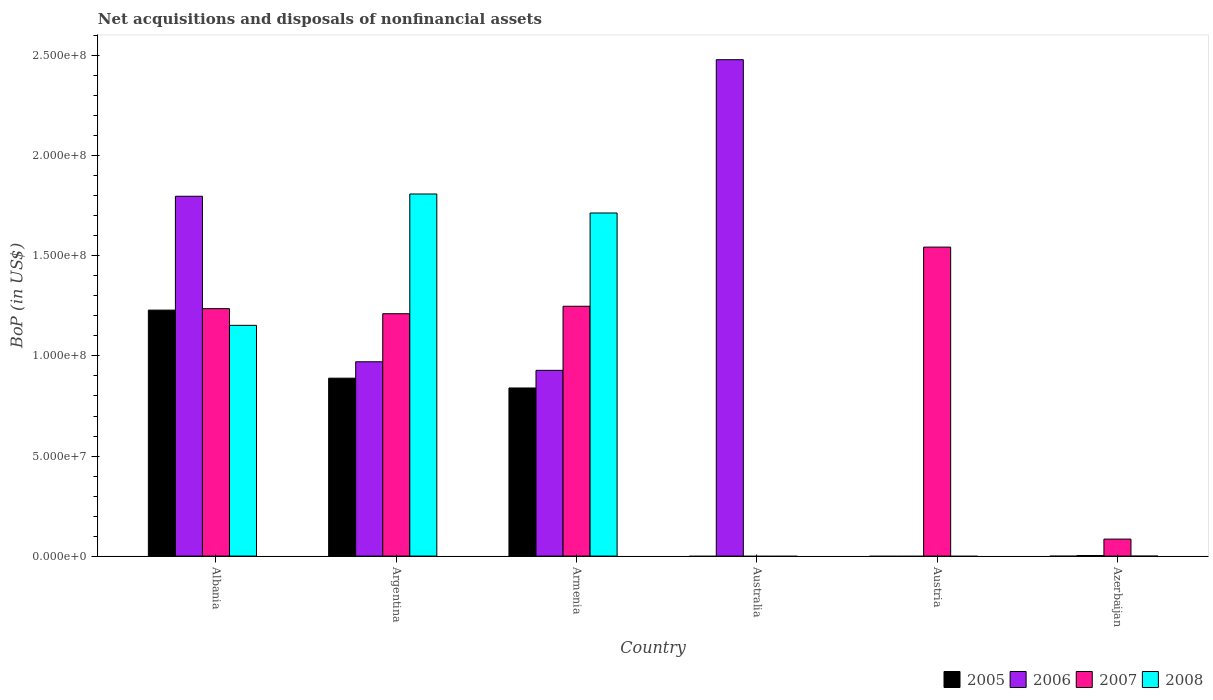How many different coloured bars are there?
Provide a succinct answer. 4. Are the number of bars per tick equal to the number of legend labels?
Provide a succinct answer. No. How many bars are there on the 5th tick from the left?
Provide a succinct answer. 1. How many bars are there on the 5th tick from the right?
Offer a terse response. 4. What is the label of the 1st group of bars from the left?
Offer a terse response. Albania. What is the Balance of Payments in 2008 in Armenia?
Your response must be concise. 1.71e+08. Across all countries, what is the maximum Balance of Payments in 2007?
Keep it short and to the point. 1.54e+08. What is the total Balance of Payments in 2005 in the graph?
Make the answer very short. 2.96e+08. What is the difference between the Balance of Payments in 2006 in Armenia and that in Azerbaijan?
Provide a short and direct response. 9.25e+07. What is the difference between the Balance of Payments in 2006 in Armenia and the Balance of Payments in 2007 in Azerbaijan?
Provide a succinct answer. 8.43e+07. What is the average Balance of Payments in 2005 per country?
Offer a terse response. 4.93e+07. What is the difference between the Balance of Payments of/in 2006 and Balance of Payments of/in 2007 in Argentina?
Provide a succinct answer. -2.40e+07. What is the ratio of the Balance of Payments in 2006 in Argentina to that in Australia?
Your answer should be very brief. 0.39. Is the difference between the Balance of Payments in 2006 in Albania and Azerbaijan greater than the difference between the Balance of Payments in 2007 in Albania and Azerbaijan?
Provide a short and direct response. Yes. What is the difference between the highest and the second highest Balance of Payments in 2008?
Make the answer very short. 9.49e+06. What is the difference between the highest and the lowest Balance of Payments in 2006?
Offer a terse response. 2.48e+08. Is it the case that in every country, the sum of the Balance of Payments in 2007 and Balance of Payments in 2008 is greater than the sum of Balance of Payments in 2005 and Balance of Payments in 2006?
Give a very brief answer. No. Is it the case that in every country, the sum of the Balance of Payments in 2006 and Balance of Payments in 2005 is greater than the Balance of Payments in 2007?
Your answer should be compact. No. Are all the bars in the graph horizontal?
Give a very brief answer. No. How many countries are there in the graph?
Your response must be concise. 6. What is the difference between two consecutive major ticks on the Y-axis?
Your answer should be very brief. 5.00e+07. Does the graph contain any zero values?
Your answer should be very brief. Yes. How are the legend labels stacked?
Ensure brevity in your answer.  Horizontal. What is the title of the graph?
Your response must be concise. Net acquisitions and disposals of nonfinancial assets. What is the label or title of the X-axis?
Give a very brief answer. Country. What is the label or title of the Y-axis?
Your answer should be very brief. BoP (in US$). What is the BoP (in US$) of 2005 in Albania?
Your answer should be compact. 1.23e+08. What is the BoP (in US$) of 2006 in Albania?
Ensure brevity in your answer.  1.80e+08. What is the BoP (in US$) in 2007 in Albania?
Provide a short and direct response. 1.24e+08. What is the BoP (in US$) in 2008 in Albania?
Provide a succinct answer. 1.15e+08. What is the BoP (in US$) in 2005 in Argentina?
Provide a succinct answer. 8.89e+07. What is the BoP (in US$) in 2006 in Argentina?
Offer a very short reply. 9.71e+07. What is the BoP (in US$) in 2007 in Argentina?
Make the answer very short. 1.21e+08. What is the BoP (in US$) in 2008 in Argentina?
Offer a terse response. 1.81e+08. What is the BoP (in US$) of 2005 in Armenia?
Your response must be concise. 8.40e+07. What is the BoP (in US$) of 2006 in Armenia?
Make the answer very short. 9.28e+07. What is the BoP (in US$) in 2007 in Armenia?
Give a very brief answer. 1.25e+08. What is the BoP (in US$) of 2008 in Armenia?
Offer a terse response. 1.71e+08. What is the BoP (in US$) of 2005 in Australia?
Give a very brief answer. 0. What is the BoP (in US$) in 2006 in Australia?
Provide a short and direct response. 2.48e+08. What is the BoP (in US$) of 2007 in Austria?
Your answer should be very brief. 1.54e+08. What is the BoP (in US$) of 2005 in Azerbaijan?
Offer a very short reply. 0. What is the BoP (in US$) in 2006 in Azerbaijan?
Keep it short and to the point. 2.85e+05. What is the BoP (in US$) in 2007 in Azerbaijan?
Ensure brevity in your answer.  8.49e+06. What is the BoP (in US$) of 2008 in Azerbaijan?
Provide a short and direct response. 0. Across all countries, what is the maximum BoP (in US$) in 2005?
Your answer should be compact. 1.23e+08. Across all countries, what is the maximum BoP (in US$) in 2006?
Keep it short and to the point. 2.48e+08. Across all countries, what is the maximum BoP (in US$) in 2007?
Make the answer very short. 1.54e+08. Across all countries, what is the maximum BoP (in US$) in 2008?
Ensure brevity in your answer.  1.81e+08. Across all countries, what is the minimum BoP (in US$) in 2005?
Provide a short and direct response. 0. Across all countries, what is the minimum BoP (in US$) of 2007?
Provide a succinct answer. 0. What is the total BoP (in US$) of 2005 in the graph?
Your answer should be compact. 2.96e+08. What is the total BoP (in US$) of 2006 in the graph?
Give a very brief answer. 6.18e+08. What is the total BoP (in US$) of 2007 in the graph?
Offer a very short reply. 5.32e+08. What is the total BoP (in US$) of 2008 in the graph?
Your answer should be very brief. 4.68e+08. What is the difference between the BoP (in US$) in 2005 in Albania and that in Argentina?
Your response must be concise. 3.40e+07. What is the difference between the BoP (in US$) in 2006 in Albania and that in Argentina?
Make the answer very short. 8.27e+07. What is the difference between the BoP (in US$) of 2007 in Albania and that in Argentina?
Offer a very short reply. 2.54e+06. What is the difference between the BoP (in US$) in 2008 in Albania and that in Argentina?
Offer a terse response. -6.56e+07. What is the difference between the BoP (in US$) in 2005 in Albania and that in Armenia?
Your response must be concise. 3.89e+07. What is the difference between the BoP (in US$) of 2006 in Albania and that in Armenia?
Your response must be concise. 8.70e+07. What is the difference between the BoP (in US$) of 2007 in Albania and that in Armenia?
Your response must be concise. -1.19e+06. What is the difference between the BoP (in US$) of 2008 in Albania and that in Armenia?
Make the answer very short. -5.61e+07. What is the difference between the BoP (in US$) of 2006 in Albania and that in Australia?
Your answer should be very brief. -6.82e+07. What is the difference between the BoP (in US$) in 2007 in Albania and that in Austria?
Offer a terse response. -3.08e+07. What is the difference between the BoP (in US$) in 2006 in Albania and that in Azerbaijan?
Offer a terse response. 1.80e+08. What is the difference between the BoP (in US$) of 2007 in Albania and that in Azerbaijan?
Ensure brevity in your answer.  1.15e+08. What is the difference between the BoP (in US$) in 2005 in Argentina and that in Armenia?
Offer a terse response. 4.90e+06. What is the difference between the BoP (in US$) in 2006 in Argentina and that in Armenia?
Give a very brief answer. 4.29e+06. What is the difference between the BoP (in US$) in 2007 in Argentina and that in Armenia?
Make the answer very short. -3.73e+06. What is the difference between the BoP (in US$) of 2008 in Argentina and that in Armenia?
Your answer should be compact. 9.49e+06. What is the difference between the BoP (in US$) in 2006 in Argentina and that in Australia?
Your response must be concise. -1.51e+08. What is the difference between the BoP (in US$) of 2007 in Argentina and that in Austria?
Give a very brief answer. -3.33e+07. What is the difference between the BoP (in US$) of 2006 in Argentina and that in Azerbaijan?
Make the answer very short. 9.68e+07. What is the difference between the BoP (in US$) of 2007 in Argentina and that in Azerbaijan?
Offer a very short reply. 1.13e+08. What is the difference between the BoP (in US$) in 2006 in Armenia and that in Australia?
Your answer should be very brief. -1.55e+08. What is the difference between the BoP (in US$) in 2007 in Armenia and that in Austria?
Your answer should be compact. -2.96e+07. What is the difference between the BoP (in US$) of 2006 in Armenia and that in Azerbaijan?
Your answer should be compact. 9.25e+07. What is the difference between the BoP (in US$) in 2007 in Armenia and that in Azerbaijan?
Provide a short and direct response. 1.16e+08. What is the difference between the BoP (in US$) of 2006 in Australia and that in Azerbaijan?
Offer a very short reply. 2.48e+08. What is the difference between the BoP (in US$) of 2007 in Austria and that in Azerbaijan?
Provide a succinct answer. 1.46e+08. What is the difference between the BoP (in US$) in 2005 in Albania and the BoP (in US$) in 2006 in Argentina?
Offer a very short reply. 2.58e+07. What is the difference between the BoP (in US$) of 2005 in Albania and the BoP (in US$) of 2007 in Argentina?
Provide a succinct answer. 1.81e+06. What is the difference between the BoP (in US$) in 2005 in Albania and the BoP (in US$) in 2008 in Argentina?
Offer a very short reply. -5.80e+07. What is the difference between the BoP (in US$) of 2006 in Albania and the BoP (in US$) of 2007 in Argentina?
Your answer should be compact. 5.87e+07. What is the difference between the BoP (in US$) in 2006 in Albania and the BoP (in US$) in 2008 in Argentina?
Offer a very short reply. -1.13e+06. What is the difference between the BoP (in US$) in 2007 in Albania and the BoP (in US$) in 2008 in Argentina?
Offer a very short reply. -5.73e+07. What is the difference between the BoP (in US$) in 2005 in Albania and the BoP (in US$) in 2006 in Armenia?
Keep it short and to the point. 3.01e+07. What is the difference between the BoP (in US$) of 2005 in Albania and the BoP (in US$) of 2007 in Armenia?
Keep it short and to the point. -1.92e+06. What is the difference between the BoP (in US$) of 2005 in Albania and the BoP (in US$) of 2008 in Armenia?
Offer a terse response. -4.85e+07. What is the difference between the BoP (in US$) in 2006 in Albania and the BoP (in US$) in 2007 in Armenia?
Your answer should be very brief. 5.50e+07. What is the difference between the BoP (in US$) in 2006 in Albania and the BoP (in US$) in 2008 in Armenia?
Provide a short and direct response. 8.36e+06. What is the difference between the BoP (in US$) of 2007 in Albania and the BoP (in US$) of 2008 in Armenia?
Offer a terse response. -4.78e+07. What is the difference between the BoP (in US$) of 2005 in Albania and the BoP (in US$) of 2006 in Australia?
Keep it short and to the point. -1.25e+08. What is the difference between the BoP (in US$) of 2005 in Albania and the BoP (in US$) of 2007 in Austria?
Your answer should be very brief. -3.15e+07. What is the difference between the BoP (in US$) in 2006 in Albania and the BoP (in US$) in 2007 in Austria?
Offer a very short reply. 2.54e+07. What is the difference between the BoP (in US$) in 2005 in Albania and the BoP (in US$) in 2006 in Azerbaijan?
Provide a short and direct response. 1.23e+08. What is the difference between the BoP (in US$) of 2005 in Albania and the BoP (in US$) of 2007 in Azerbaijan?
Make the answer very short. 1.14e+08. What is the difference between the BoP (in US$) of 2006 in Albania and the BoP (in US$) of 2007 in Azerbaijan?
Your answer should be very brief. 1.71e+08. What is the difference between the BoP (in US$) of 2005 in Argentina and the BoP (in US$) of 2006 in Armenia?
Your answer should be compact. -3.91e+06. What is the difference between the BoP (in US$) of 2005 in Argentina and the BoP (in US$) of 2007 in Armenia?
Keep it short and to the point. -3.59e+07. What is the difference between the BoP (in US$) in 2005 in Argentina and the BoP (in US$) in 2008 in Armenia?
Give a very brief answer. -8.25e+07. What is the difference between the BoP (in US$) of 2006 in Argentina and the BoP (in US$) of 2007 in Armenia?
Keep it short and to the point. -2.77e+07. What is the difference between the BoP (in US$) of 2006 in Argentina and the BoP (in US$) of 2008 in Armenia?
Provide a succinct answer. -7.43e+07. What is the difference between the BoP (in US$) in 2007 in Argentina and the BoP (in US$) in 2008 in Armenia?
Offer a terse response. -5.03e+07. What is the difference between the BoP (in US$) in 2005 in Argentina and the BoP (in US$) in 2006 in Australia?
Give a very brief answer. -1.59e+08. What is the difference between the BoP (in US$) in 2005 in Argentina and the BoP (in US$) in 2007 in Austria?
Make the answer very short. -6.55e+07. What is the difference between the BoP (in US$) of 2006 in Argentina and the BoP (in US$) of 2007 in Austria?
Your answer should be very brief. -5.73e+07. What is the difference between the BoP (in US$) of 2005 in Argentina and the BoP (in US$) of 2006 in Azerbaijan?
Your response must be concise. 8.86e+07. What is the difference between the BoP (in US$) in 2005 in Argentina and the BoP (in US$) in 2007 in Azerbaijan?
Keep it short and to the point. 8.04e+07. What is the difference between the BoP (in US$) in 2006 in Argentina and the BoP (in US$) in 2007 in Azerbaijan?
Your answer should be compact. 8.86e+07. What is the difference between the BoP (in US$) in 2005 in Armenia and the BoP (in US$) in 2006 in Australia?
Keep it short and to the point. -1.64e+08. What is the difference between the BoP (in US$) in 2005 in Armenia and the BoP (in US$) in 2007 in Austria?
Keep it short and to the point. -7.04e+07. What is the difference between the BoP (in US$) of 2006 in Armenia and the BoP (in US$) of 2007 in Austria?
Offer a very short reply. -6.16e+07. What is the difference between the BoP (in US$) of 2005 in Armenia and the BoP (in US$) of 2006 in Azerbaijan?
Your answer should be compact. 8.37e+07. What is the difference between the BoP (in US$) of 2005 in Armenia and the BoP (in US$) of 2007 in Azerbaijan?
Your answer should be very brief. 7.55e+07. What is the difference between the BoP (in US$) of 2006 in Armenia and the BoP (in US$) of 2007 in Azerbaijan?
Offer a terse response. 8.43e+07. What is the difference between the BoP (in US$) of 2006 in Australia and the BoP (in US$) of 2007 in Austria?
Your answer should be very brief. 9.36e+07. What is the difference between the BoP (in US$) in 2006 in Australia and the BoP (in US$) in 2007 in Azerbaijan?
Your response must be concise. 2.40e+08. What is the average BoP (in US$) in 2005 per country?
Provide a short and direct response. 4.93e+07. What is the average BoP (in US$) in 2006 per country?
Your answer should be very brief. 1.03e+08. What is the average BoP (in US$) of 2007 per country?
Provide a succinct answer. 8.87e+07. What is the average BoP (in US$) in 2008 per country?
Offer a terse response. 7.79e+07. What is the difference between the BoP (in US$) of 2005 and BoP (in US$) of 2006 in Albania?
Offer a terse response. -5.69e+07. What is the difference between the BoP (in US$) of 2005 and BoP (in US$) of 2007 in Albania?
Provide a succinct answer. -7.29e+05. What is the difference between the BoP (in US$) in 2005 and BoP (in US$) in 2008 in Albania?
Your answer should be compact. 7.61e+06. What is the difference between the BoP (in US$) of 2006 and BoP (in US$) of 2007 in Albania?
Your answer should be very brief. 5.62e+07. What is the difference between the BoP (in US$) in 2006 and BoP (in US$) in 2008 in Albania?
Make the answer very short. 6.45e+07. What is the difference between the BoP (in US$) of 2007 and BoP (in US$) of 2008 in Albania?
Offer a terse response. 8.34e+06. What is the difference between the BoP (in US$) in 2005 and BoP (in US$) in 2006 in Argentina?
Make the answer very short. -8.20e+06. What is the difference between the BoP (in US$) in 2005 and BoP (in US$) in 2007 in Argentina?
Your response must be concise. -3.22e+07. What is the difference between the BoP (in US$) of 2005 and BoP (in US$) of 2008 in Argentina?
Your answer should be compact. -9.20e+07. What is the difference between the BoP (in US$) of 2006 and BoP (in US$) of 2007 in Argentina?
Offer a very short reply. -2.40e+07. What is the difference between the BoP (in US$) in 2006 and BoP (in US$) in 2008 in Argentina?
Make the answer very short. -8.38e+07. What is the difference between the BoP (in US$) in 2007 and BoP (in US$) in 2008 in Argentina?
Your answer should be compact. -5.98e+07. What is the difference between the BoP (in US$) of 2005 and BoP (in US$) of 2006 in Armenia?
Ensure brevity in your answer.  -8.81e+06. What is the difference between the BoP (in US$) of 2005 and BoP (in US$) of 2007 in Armenia?
Give a very brief answer. -4.08e+07. What is the difference between the BoP (in US$) in 2005 and BoP (in US$) in 2008 in Armenia?
Ensure brevity in your answer.  -8.74e+07. What is the difference between the BoP (in US$) of 2006 and BoP (in US$) of 2007 in Armenia?
Your answer should be compact. -3.20e+07. What is the difference between the BoP (in US$) in 2006 and BoP (in US$) in 2008 in Armenia?
Make the answer very short. -7.86e+07. What is the difference between the BoP (in US$) of 2007 and BoP (in US$) of 2008 in Armenia?
Keep it short and to the point. -4.66e+07. What is the difference between the BoP (in US$) of 2006 and BoP (in US$) of 2007 in Azerbaijan?
Your answer should be very brief. -8.21e+06. What is the ratio of the BoP (in US$) of 2005 in Albania to that in Argentina?
Offer a very short reply. 1.38. What is the ratio of the BoP (in US$) in 2006 in Albania to that in Argentina?
Provide a short and direct response. 1.85. What is the ratio of the BoP (in US$) in 2007 in Albania to that in Argentina?
Provide a short and direct response. 1.02. What is the ratio of the BoP (in US$) in 2008 in Albania to that in Argentina?
Provide a short and direct response. 0.64. What is the ratio of the BoP (in US$) in 2005 in Albania to that in Armenia?
Keep it short and to the point. 1.46. What is the ratio of the BoP (in US$) in 2006 in Albania to that in Armenia?
Your answer should be compact. 1.94. What is the ratio of the BoP (in US$) of 2008 in Albania to that in Armenia?
Your answer should be very brief. 0.67. What is the ratio of the BoP (in US$) in 2006 in Albania to that in Australia?
Make the answer very short. 0.72. What is the ratio of the BoP (in US$) of 2007 in Albania to that in Austria?
Provide a succinct answer. 0.8. What is the ratio of the BoP (in US$) in 2006 in Albania to that in Azerbaijan?
Make the answer very short. 630.87. What is the ratio of the BoP (in US$) in 2007 in Albania to that in Azerbaijan?
Provide a short and direct response. 14.56. What is the ratio of the BoP (in US$) in 2005 in Argentina to that in Armenia?
Ensure brevity in your answer.  1.06. What is the ratio of the BoP (in US$) in 2006 in Argentina to that in Armenia?
Your answer should be compact. 1.05. What is the ratio of the BoP (in US$) of 2007 in Argentina to that in Armenia?
Provide a short and direct response. 0.97. What is the ratio of the BoP (in US$) of 2008 in Argentina to that in Armenia?
Keep it short and to the point. 1.06. What is the ratio of the BoP (in US$) of 2006 in Argentina to that in Australia?
Keep it short and to the point. 0.39. What is the ratio of the BoP (in US$) of 2007 in Argentina to that in Austria?
Provide a succinct answer. 0.78. What is the ratio of the BoP (in US$) in 2006 in Argentina to that in Azerbaijan?
Your response must be concise. 340.7. What is the ratio of the BoP (in US$) in 2007 in Argentina to that in Azerbaijan?
Keep it short and to the point. 14.26. What is the ratio of the BoP (in US$) in 2006 in Armenia to that in Australia?
Offer a very short reply. 0.37. What is the ratio of the BoP (in US$) of 2007 in Armenia to that in Austria?
Your response must be concise. 0.81. What is the ratio of the BoP (in US$) in 2006 in Armenia to that in Azerbaijan?
Your answer should be very brief. 325.66. What is the ratio of the BoP (in US$) of 2006 in Australia to that in Azerbaijan?
Offer a very short reply. 870.29. What is the ratio of the BoP (in US$) of 2007 in Austria to that in Azerbaijan?
Keep it short and to the point. 18.18. What is the difference between the highest and the second highest BoP (in US$) of 2005?
Provide a short and direct response. 3.40e+07. What is the difference between the highest and the second highest BoP (in US$) in 2006?
Offer a very short reply. 6.82e+07. What is the difference between the highest and the second highest BoP (in US$) of 2007?
Offer a very short reply. 2.96e+07. What is the difference between the highest and the second highest BoP (in US$) in 2008?
Offer a terse response. 9.49e+06. What is the difference between the highest and the lowest BoP (in US$) of 2005?
Your response must be concise. 1.23e+08. What is the difference between the highest and the lowest BoP (in US$) in 2006?
Make the answer very short. 2.48e+08. What is the difference between the highest and the lowest BoP (in US$) in 2007?
Provide a succinct answer. 1.54e+08. What is the difference between the highest and the lowest BoP (in US$) in 2008?
Provide a succinct answer. 1.81e+08. 